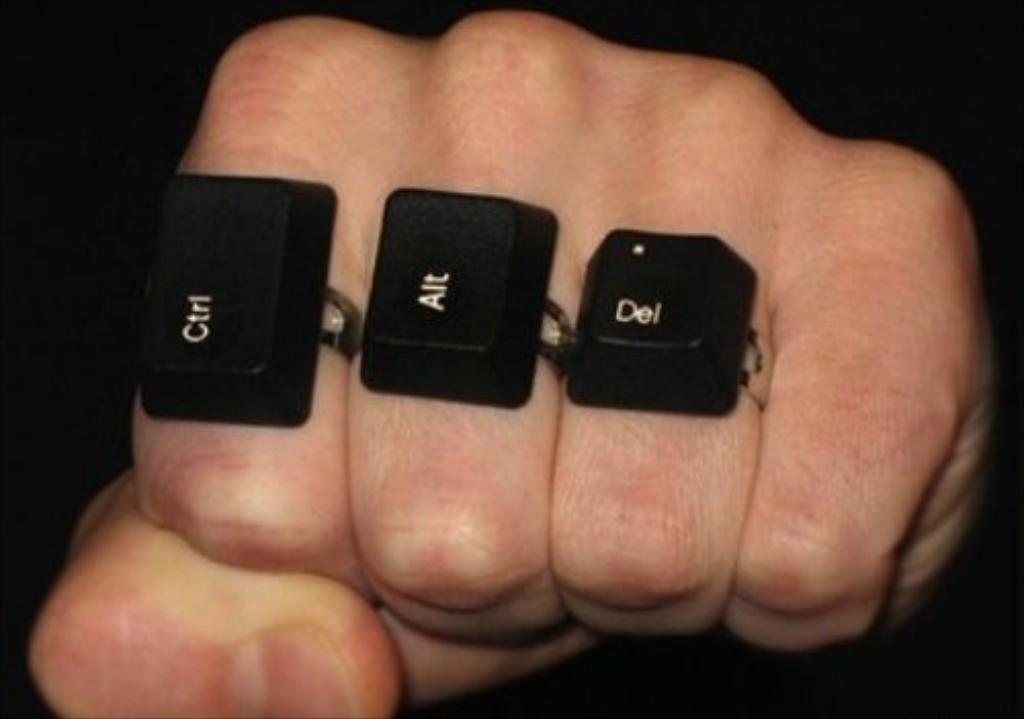What is the main subject of the image? The main subject of the image is a human hand. What objects can be seen on the hand? There are three black rings on the hand. What color is the background of the image? The background of the image is black. How does the goldfish react to the rings in the image? There is no goldfish present in the image, so it cannot react to the rings. 